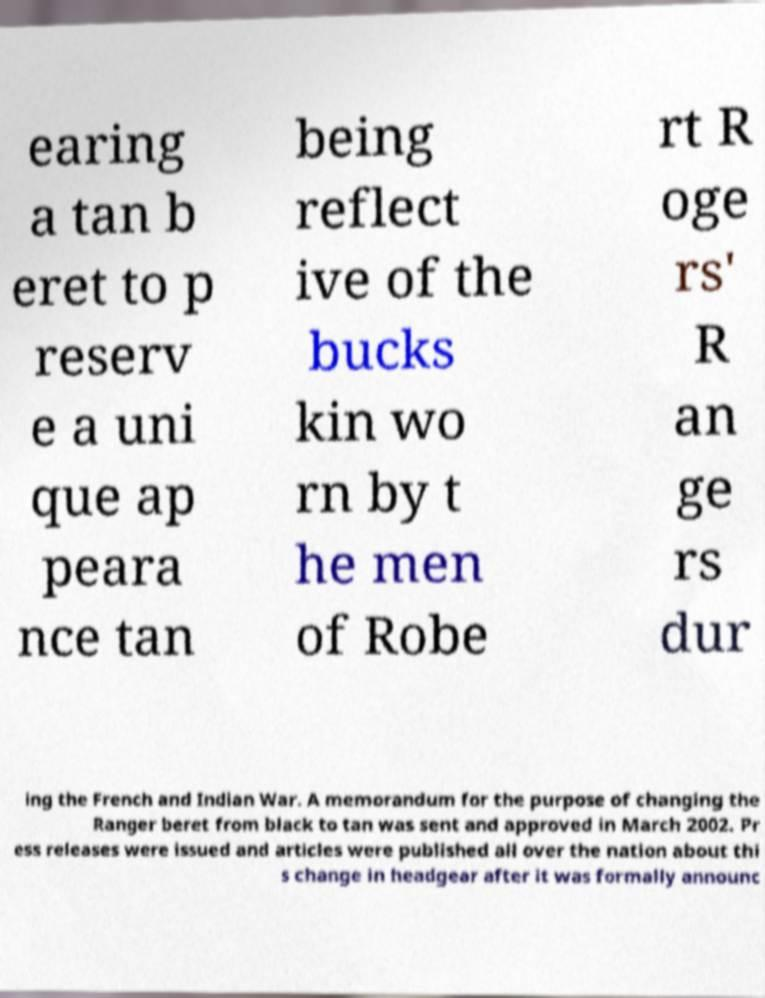For documentation purposes, I need the text within this image transcribed. Could you provide that? earing a tan b eret to p reserv e a uni que ap peara nce tan being reflect ive of the bucks kin wo rn by t he men of Robe rt R oge rs' R an ge rs dur ing the French and Indian War. A memorandum for the purpose of changing the Ranger beret from black to tan was sent and approved in March 2002. Pr ess releases were issued and articles were published all over the nation about thi s change in headgear after it was formally announc 